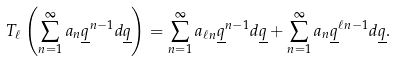Convert formula to latex. <formula><loc_0><loc_0><loc_500><loc_500>T _ { \ell } \left ( \sum _ { n = 1 } ^ { \infty } a _ { n } \underline { q } ^ { n - 1 } d \underline { q } \right ) = \sum _ { n = 1 } ^ { \infty } a _ { \ell n } \underline { q } ^ { n - 1 } d \underline { q } + \sum _ { n = 1 } ^ { \infty } a _ { n } \underline { q } ^ { \ell n - 1 } d \underline { q } .</formula> 